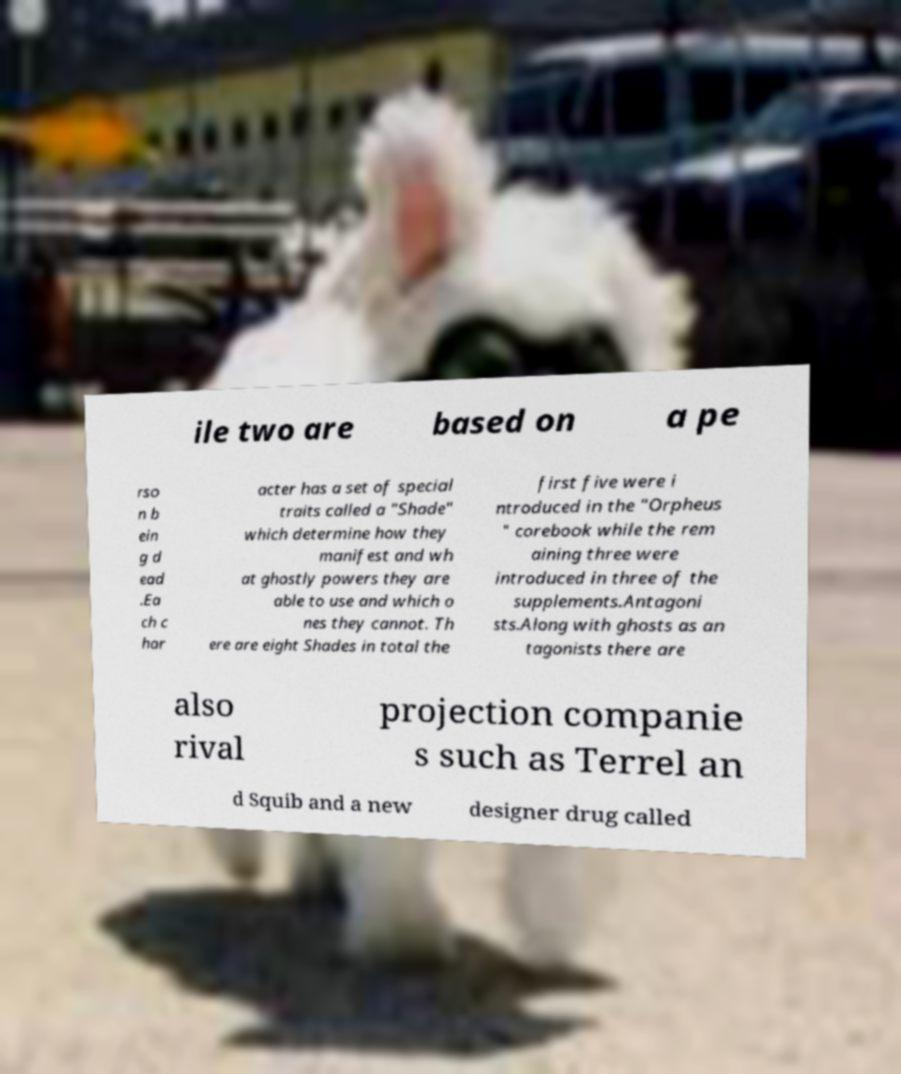For documentation purposes, I need the text within this image transcribed. Could you provide that? ile two are based on a pe rso n b ein g d ead .Ea ch c har acter has a set of special traits called a "Shade" which determine how they manifest and wh at ghostly powers they are able to use and which o nes they cannot. Th ere are eight Shades in total the first five were i ntroduced in the "Orpheus " corebook while the rem aining three were introduced in three of the supplements.Antagoni sts.Along with ghosts as an tagonists there are also rival projection companie s such as Terrel an d Squib and a new designer drug called 